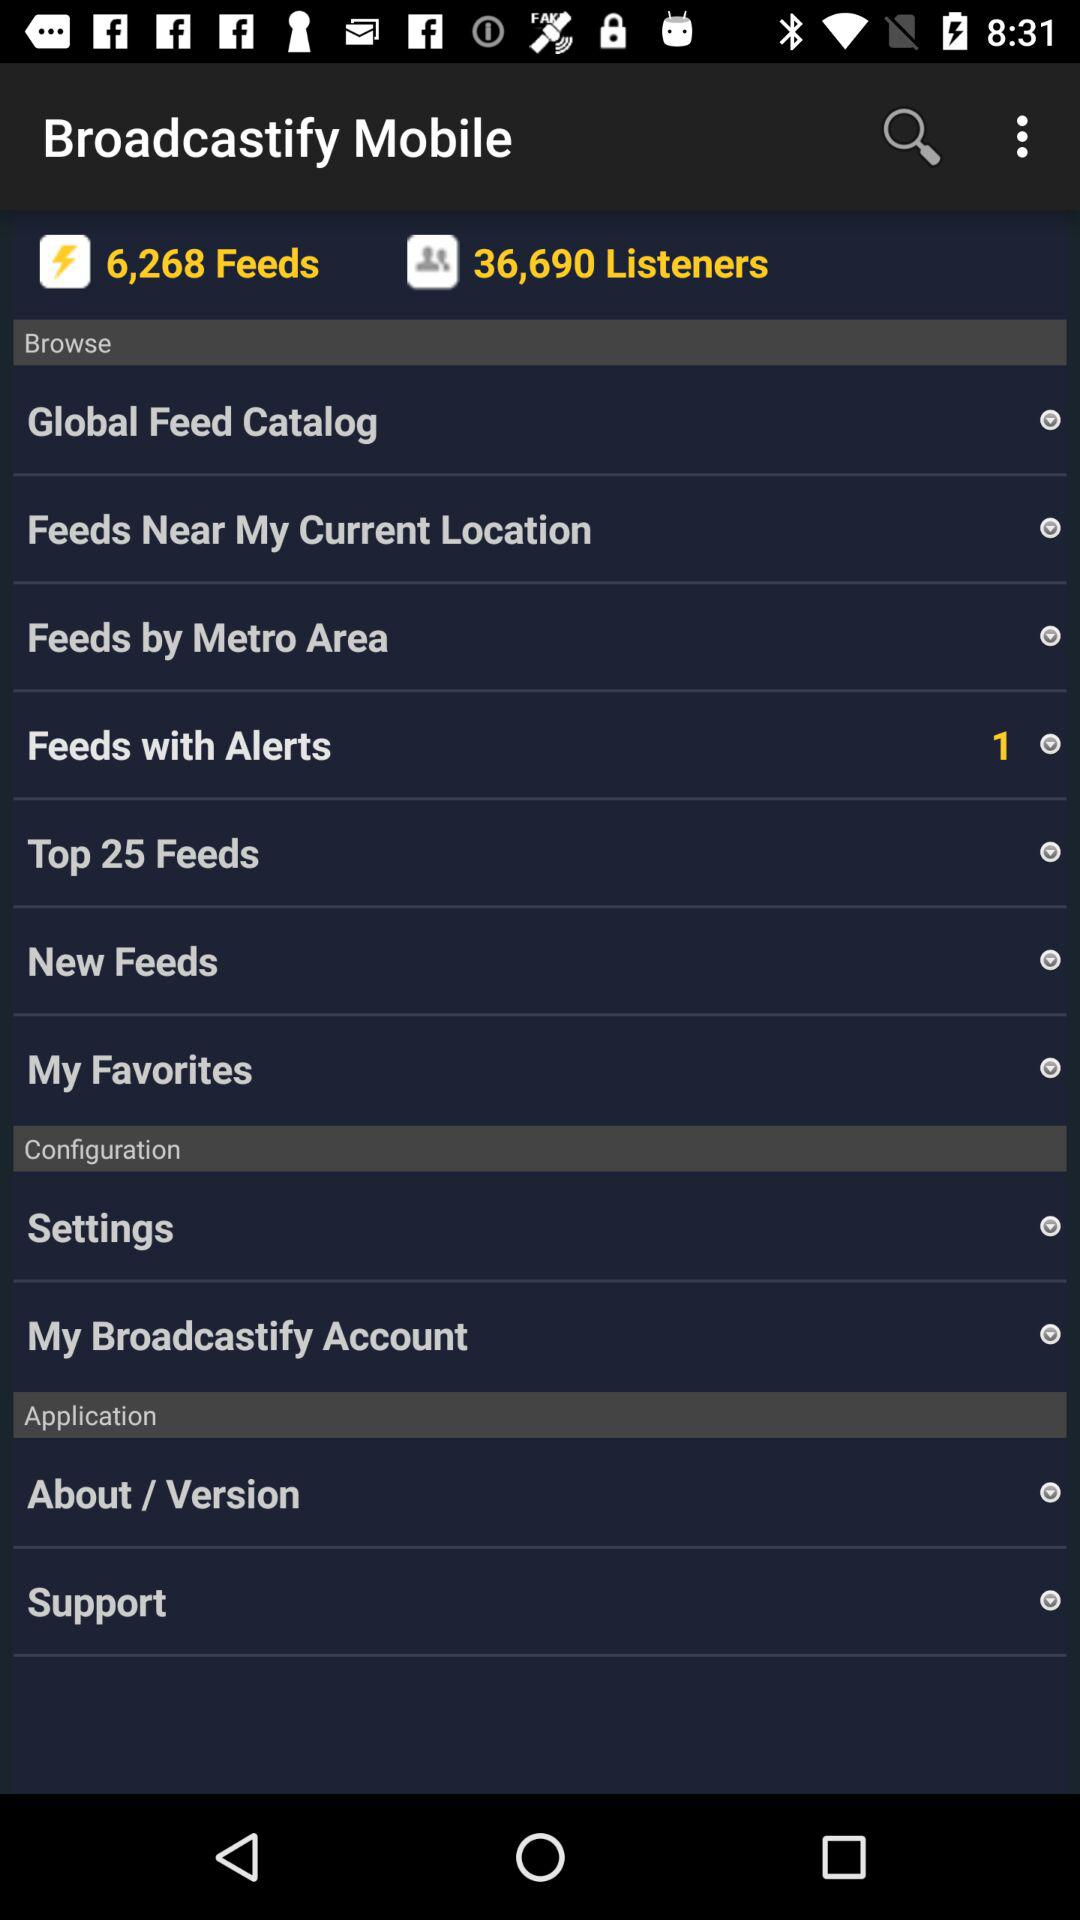How many notifications are there in "Settings"?
When the provided information is insufficient, respond with <no answer>. <no answer> 